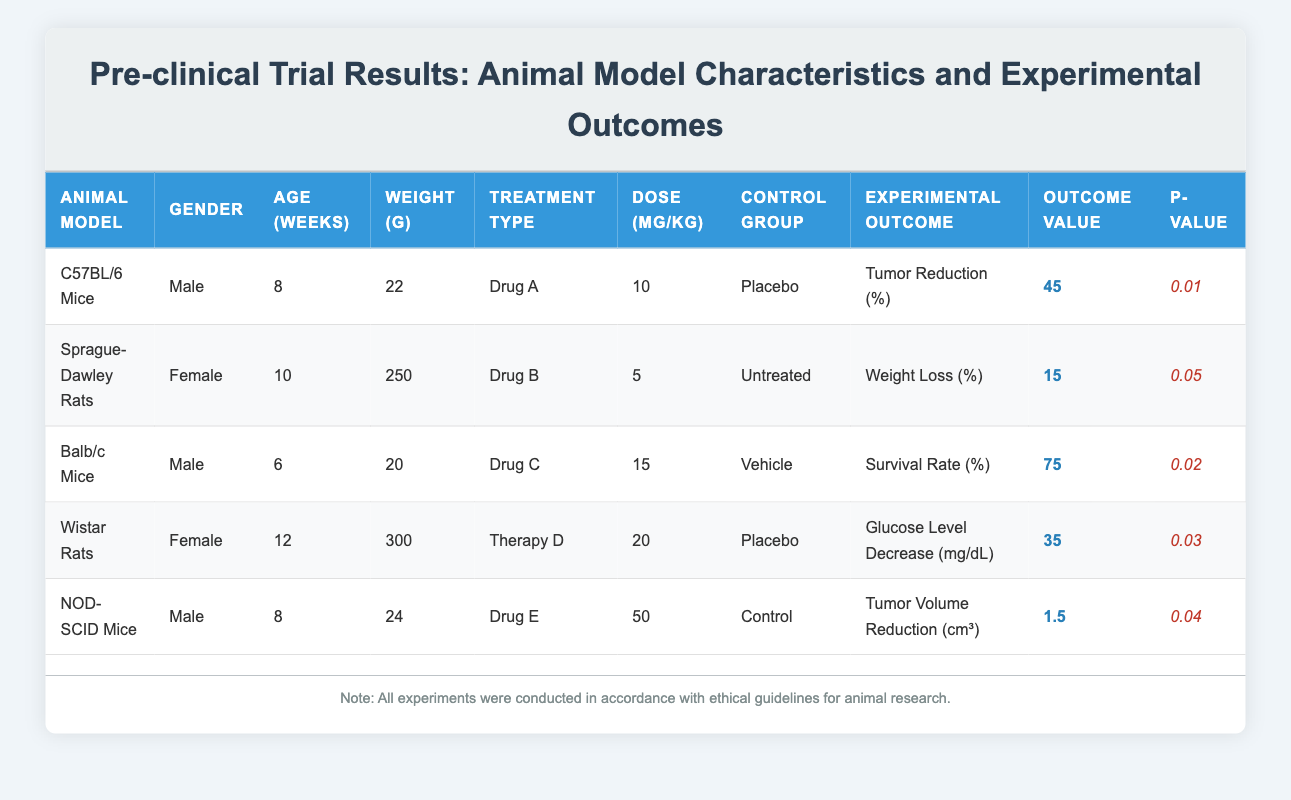What is the outcome value for the Tumor Reduction percentage in C57BL/6 Mice? The table specifies that the experimental outcome for C57BL/6 Mice regarding Tumor Reduction is 45%.
Answer: 45% Which treatment type had the highest outcome value? By examining the Outcome Values in the table: 45% (Drug A), 15% (Drug B), 75% (Drug C), 35 (Therapy D), and 1.5 cm³ (Drug E). The highest value is 75% for Drug C.
Answer: Drug C Is the average weight of the animal models used in the trials more than 100 grams? The weights listed are: 22g (C57BL/6 Mice), 250g (Sprague-Dawley Rats), 20g (Balb/c Mice), 300g (Wistar Rats), and 24g (NOD-SCID Mice). The average weight is (22 + 250 + 20 + 300 + 24) / 5 = 73.2g, which is less than 100g.
Answer: No How many experimental outcomes involve tumor-related measurements? The table includes "Tumor Reduction (%)" for C57BL/6 Mice and "Tumor Volume Reduction (cm³)" for NOD-SCID Mice. Therefore, there are 2 outcomes involved in tumor-related measurements.
Answer: 2 What is the P-value associated with the greatest outcome value? The highest outcome value is 75% for Drug C with a P-value of 0.02. Therefore, the P-value associated with the greatest outcome value is 0.02.
Answer: 0.02 Which animal model had the lowest weight, and what was the outcome value associated with it? The lowest weight is 20g for Balb/c Mice, which has an outcome value of 75% for survival rate.
Answer: 75% Is Drug B's outcome value statistically significant? The outcome value for Drug B is 15% with a P-value of 0.05. Since P-values less than 0.05 are generally considered significant, the result is on the threshold of significance.
Answer: Yes What is the difference between the outcome values of Drug A and Drug C? The outcome value for Drug A is 45% and for Drug C is 75%. The difference is calculated as 75% - 45% = 30%.
Answer: 30% What percentage of female animals was involved in this data set? There are 2 female animal models (Sprague-Dawley Rats and Wistar Rats) out of a total of 5 models, resulting in (2/5) * 100% = 40%.
Answer: 40% 